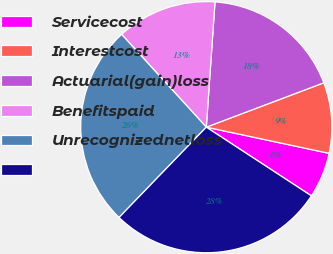Convert chart to OTSL. <chart><loc_0><loc_0><loc_500><loc_500><pie_chart><fcel>Servicecost<fcel>Interestcost<fcel>Actuarial(gain)loss<fcel>Benefitspaid<fcel>Unrecognizednetloss<fcel>Unnamed: 5<nl><fcel>5.87%<fcel>9.09%<fcel>18.15%<fcel>12.88%<fcel>26.0%<fcel>28.01%<nl></chart> 